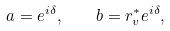<formula> <loc_0><loc_0><loc_500><loc_500>a = e ^ { i \delta } , \quad b = r _ { v } ^ { * } e ^ { i \delta } ,</formula> 